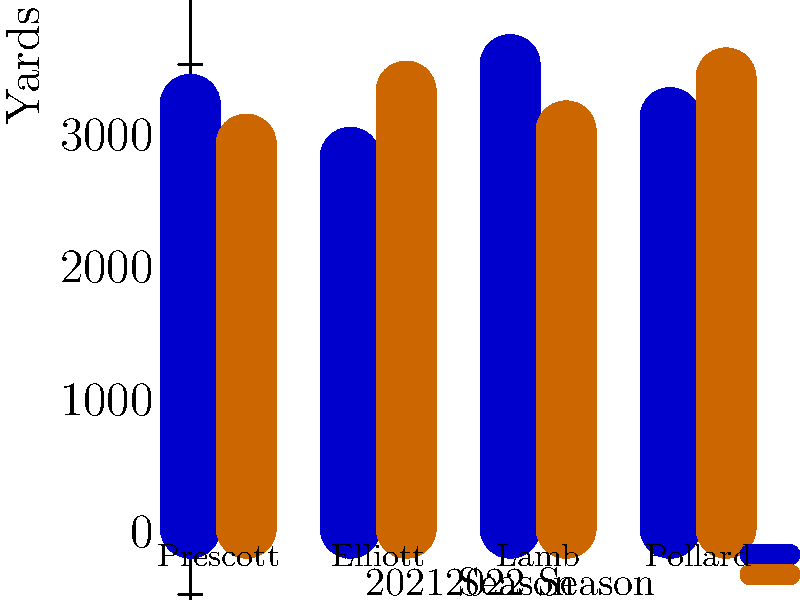Based on the bar graph comparing the total yards gained by key Dallas Cowboys players in the 2021 and 2022 seasons, which player showed the most improvement from 2021 to 2022? To determine which player showed the most improvement, we need to compare the difference in yards between 2021 and 2022 for each player:

1. Dak Prescott:
   2021: 3200 yards
   2022: 2900 yards
   Difference: 2900 - 3200 = -300 yards (decline)

2. Ezekiel Elliott:
   2021: 2800 yards
   2022: 3300 yards
   Difference: 3300 - 2800 = +500 yards (improvement)

3. CeeDee Lamb:
   2021: 3500 yards
   2022: 3000 yards
   Difference: 3000 - 3500 = -500 yards (decline)

4. Tony Pollard:
   2021: 3100 yards
   2022: 3400 yards
   Difference: 3400 - 3100 = +300 yards (improvement)

Ezekiel Elliott showed the largest positive difference of 500 yards, indicating the most improvement from 2021 to 2022.
Answer: Ezekiel Elliott 